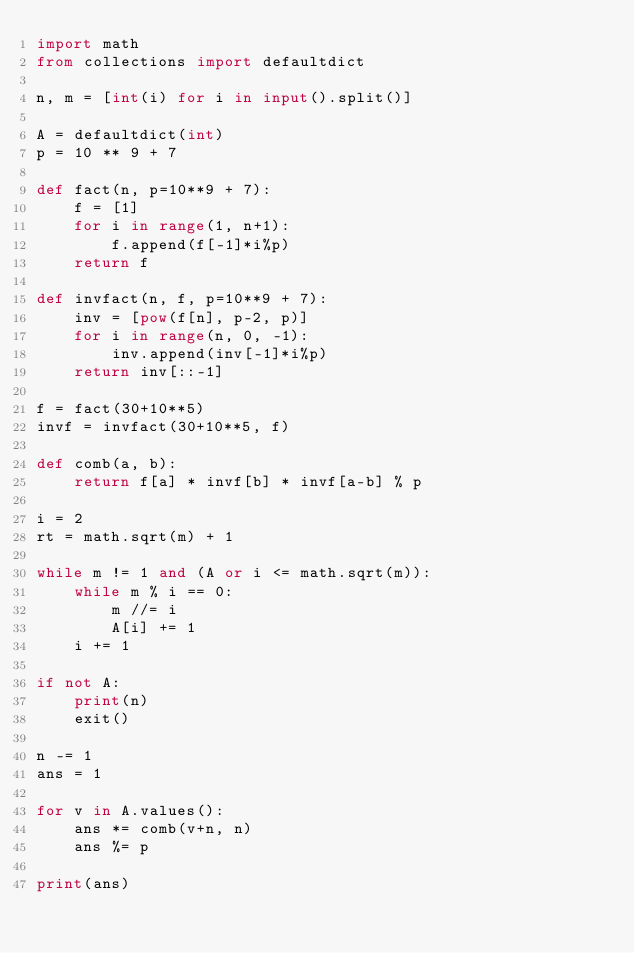Convert code to text. <code><loc_0><loc_0><loc_500><loc_500><_Python_>import math
from collections import defaultdict

n, m = [int(i) for i in input().split()]

A = defaultdict(int)
p = 10 ** 9 + 7

def fact(n, p=10**9 + 7):
    f = [1]
    for i in range(1, n+1):
        f.append(f[-1]*i%p)
    return f

def invfact(n, f, p=10**9 + 7):
    inv = [pow(f[n], p-2, p)]
    for i in range(n, 0, -1):
        inv.append(inv[-1]*i%p)
    return inv[::-1]

f = fact(30+10**5)
invf = invfact(30+10**5, f)

def comb(a, b):
    return f[a] * invf[b] * invf[a-b] % p

i = 2
rt = math.sqrt(m) + 1

while m != 1 and (A or i <= math.sqrt(m)):
    while m % i == 0:
        m //= i
        A[i] += 1
    i += 1

if not A:
    print(n)
    exit()

n -= 1
ans = 1

for v in A.values():
    ans *= comb(v+n, n)
    ans %= p

print(ans)</code> 